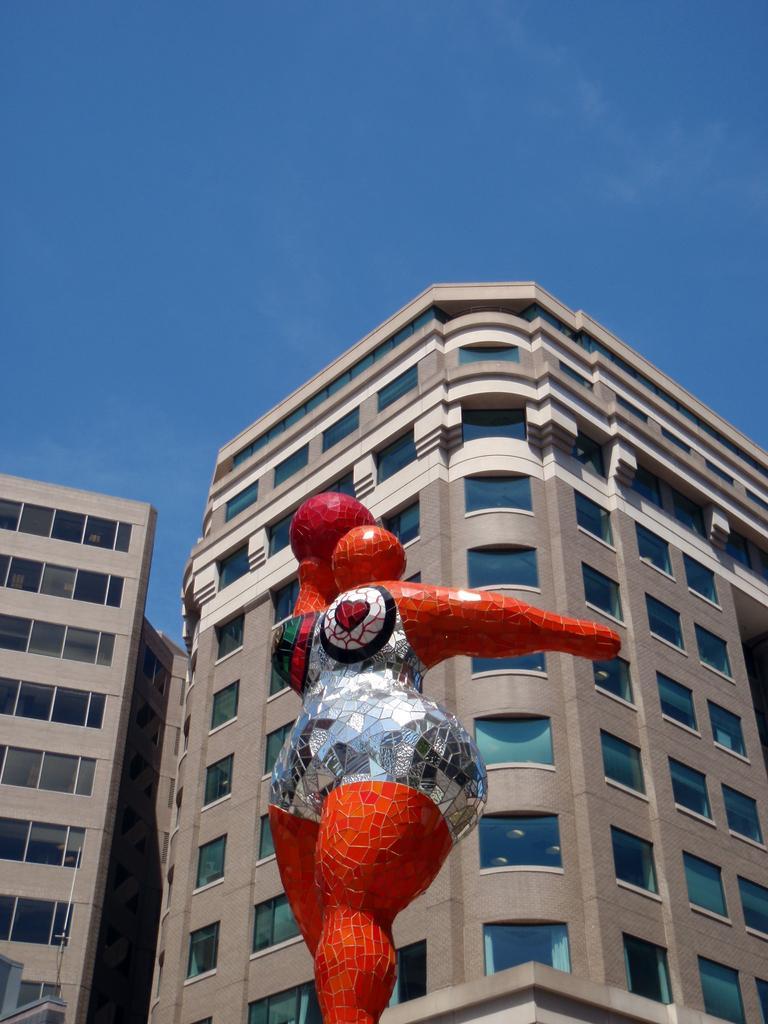Describe this image in one or two sentences. In the middle of the image, there is a statue in orange and silver color combination, holding a red color object. In the background, there are buildings having glass windows and there are clouds in the blue sky. 